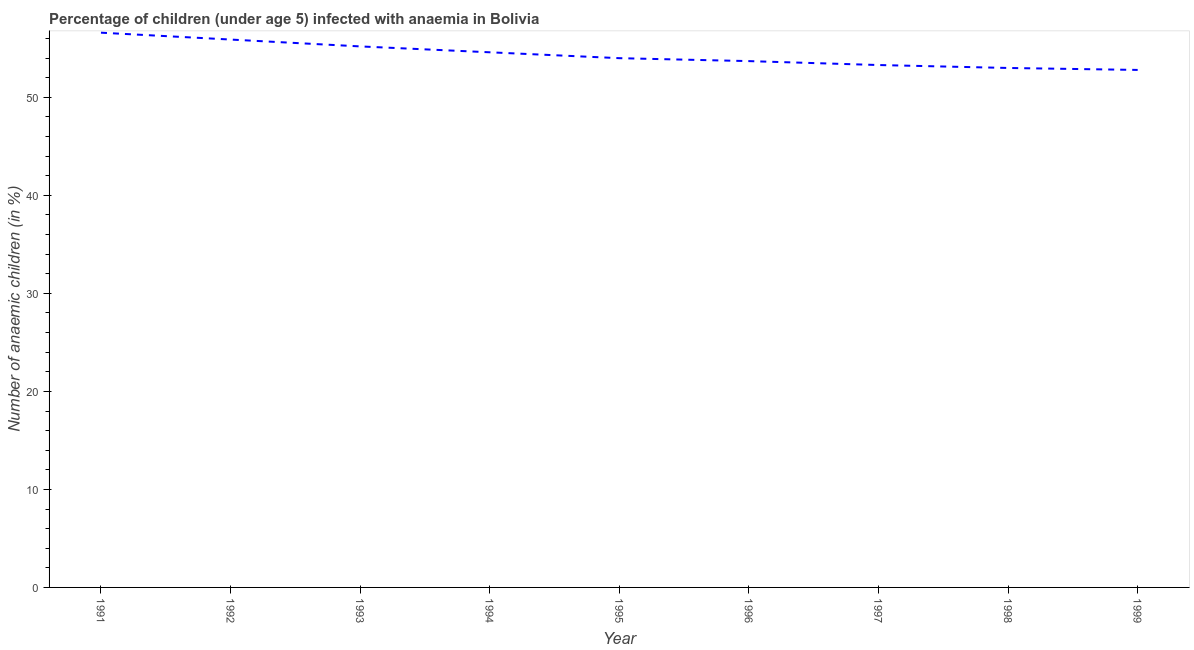What is the number of anaemic children in 1991?
Provide a short and direct response. 56.6. Across all years, what is the maximum number of anaemic children?
Give a very brief answer. 56.6. Across all years, what is the minimum number of anaemic children?
Make the answer very short. 52.8. In which year was the number of anaemic children maximum?
Offer a terse response. 1991. What is the sum of the number of anaemic children?
Give a very brief answer. 489.1. What is the difference between the number of anaemic children in 1992 and 1998?
Offer a terse response. 2.9. What is the average number of anaemic children per year?
Give a very brief answer. 54.34. What is the median number of anaemic children?
Keep it short and to the point. 54. In how many years, is the number of anaemic children greater than 46 %?
Make the answer very short. 9. Do a majority of the years between 1996 and 1991 (inclusive) have number of anaemic children greater than 26 %?
Your answer should be very brief. Yes. What is the ratio of the number of anaemic children in 1995 to that in 1999?
Make the answer very short. 1.02. Is the number of anaemic children in 1991 less than that in 1997?
Your response must be concise. No. Is the difference between the number of anaemic children in 1997 and 1999 greater than the difference between any two years?
Keep it short and to the point. No. What is the difference between the highest and the second highest number of anaemic children?
Your response must be concise. 0.7. What is the difference between the highest and the lowest number of anaemic children?
Ensure brevity in your answer.  3.8. Does the number of anaemic children monotonically increase over the years?
Provide a succinct answer. No. What is the difference between two consecutive major ticks on the Y-axis?
Provide a succinct answer. 10. What is the title of the graph?
Your response must be concise. Percentage of children (under age 5) infected with anaemia in Bolivia. What is the label or title of the X-axis?
Offer a very short reply. Year. What is the label or title of the Y-axis?
Your answer should be compact. Number of anaemic children (in %). What is the Number of anaemic children (in %) in 1991?
Make the answer very short. 56.6. What is the Number of anaemic children (in %) in 1992?
Offer a very short reply. 55.9. What is the Number of anaemic children (in %) in 1993?
Ensure brevity in your answer.  55.2. What is the Number of anaemic children (in %) of 1994?
Provide a succinct answer. 54.6. What is the Number of anaemic children (in %) of 1995?
Ensure brevity in your answer.  54. What is the Number of anaemic children (in %) of 1996?
Provide a short and direct response. 53.7. What is the Number of anaemic children (in %) of 1997?
Your answer should be compact. 53.3. What is the Number of anaemic children (in %) of 1999?
Keep it short and to the point. 52.8. What is the difference between the Number of anaemic children (in %) in 1991 and 1992?
Your response must be concise. 0.7. What is the difference between the Number of anaemic children (in %) in 1991 and 1993?
Provide a short and direct response. 1.4. What is the difference between the Number of anaemic children (in %) in 1991 and 1994?
Offer a terse response. 2. What is the difference between the Number of anaemic children (in %) in 1991 and 1996?
Keep it short and to the point. 2.9. What is the difference between the Number of anaemic children (in %) in 1991 and 1997?
Provide a succinct answer. 3.3. What is the difference between the Number of anaemic children (in %) in 1991 and 1999?
Your response must be concise. 3.8. What is the difference between the Number of anaemic children (in %) in 1992 and 1994?
Keep it short and to the point. 1.3. What is the difference between the Number of anaemic children (in %) in 1992 and 1995?
Offer a terse response. 1.9. What is the difference between the Number of anaemic children (in %) in 1992 and 1996?
Provide a succinct answer. 2.2. What is the difference between the Number of anaemic children (in %) in 1992 and 1997?
Provide a short and direct response. 2.6. What is the difference between the Number of anaemic children (in %) in 1993 and 1994?
Keep it short and to the point. 0.6. What is the difference between the Number of anaemic children (in %) in 1993 and 1995?
Offer a very short reply. 1.2. What is the difference between the Number of anaemic children (in %) in 1994 and 1995?
Give a very brief answer. 0.6. What is the difference between the Number of anaemic children (in %) in 1994 and 1996?
Keep it short and to the point. 0.9. What is the difference between the Number of anaemic children (in %) in 1994 and 1997?
Provide a short and direct response. 1.3. What is the difference between the Number of anaemic children (in %) in 1994 and 1998?
Give a very brief answer. 1.6. What is the difference between the Number of anaemic children (in %) in 1995 and 1996?
Your answer should be very brief. 0.3. What is the difference between the Number of anaemic children (in %) in 1995 and 1997?
Provide a short and direct response. 0.7. What is the difference between the Number of anaemic children (in %) in 1996 and 1997?
Offer a terse response. 0.4. What is the difference between the Number of anaemic children (in %) in 1997 and 1999?
Keep it short and to the point. 0.5. What is the difference between the Number of anaemic children (in %) in 1998 and 1999?
Provide a succinct answer. 0.2. What is the ratio of the Number of anaemic children (in %) in 1991 to that in 1993?
Ensure brevity in your answer.  1.02. What is the ratio of the Number of anaemic children (in %) in 1991 to that in 1995?
Provide a short and direct response. 1.05. What is the ratio of the Number of anaemic children (in %) in 1991 to that in 1996?
Provide a short and direct response. 1.05. What is the ratio of the Number of anaemic children (in %) in 1991 to that in 1997?
Your answer should be compact. 1.06. What is the ratio of the Number of anaemic children (in %) in 1991 to that in 1998?
Provide a short and direct response. 1.07. What is the ratio of the Number of anaemic children (in %) in 1991 to that in 1999?
Keep it short and to the point. 1.07. What is the ratio of the Number of anaemic children (in %) in 1992 to that in 1993?
Provide a succinct answer. 1.01. What is the ratio of the Number of anaemic children (in %) in 1992 to that in 1994?
Offer a very short reply. 1.02. What is the ratio of the Number of anaemic children (in %) in 1992 to that in 1995?
Your answer should be compact. 1.03. What is the ratio of the Number of anaemic children (in %) in 1992 to that in 1996?
Make the answer very short. 1.04. What is the ratio of the Number of anaemic children (in %) in 1992 to that in 1997?
Keep it short and to the point. 1.05. What is the ratio of the Number of anaemic children (in %) in 1992 to that in 1998?
Offer a very short reply. 1.05. What is the ratio of the Number of anaemic children (in %) in 1992 to that in 1999?
Your answer should be very brief. 1.06. What is the ratio of the Number of anaemic children (in %) in 1993 to that in 1994?
Your response must be concise. 1.01. What is the ratio of the Number of anaemic children (in %) in 1993 to that in 1996?
Ensure brevity in your answer.  1.03. What is the ratio of the Number of anaemic children (in %) in 1993 to that in 1997?
Offer a very short reply. 1.04. What is the ratio of the Number of anaemic children (in %) in 1993 to that in 1998?
Give a very brief answer. 1.04. What is the ratio of the Number of anaemic children (in %) in 1993 to that in 1999?
Ensure brevity in your answer.  1.04. What is the ratio of the Number of anaemic children (in %) in 1994 to that in 1996?
Your answer should be very brief. 1.02. What is the ratio of the Number of anaemic children (in %) in 1994 to that in 1999?
Provide a short and direct response. 1.03. What is the ratio of the Number of anaemic children (in %) in 1995 to that in 1996?
Your answer should be compact. 1.01. What is the ratio of the Number of anaemic children (in %) in 1995 to that in 1997?
Your answer should be compact. 1.01. What is the ratio of the Number of anaemic children (in %) in 1995 to that in 1999?
Offer a terse response. 1.02. What is the ratio of the Number of anaemic children (in %) in 1996 to that in 1997?
Provide a short and direct response. 1.01. What is the ratio of the Number of anaemic children (in %) in 1996 to that in 1999?
Make the answer very short. 1.02. What is the ratio of the Number of anaemic children (in %) in 1997 to that in 1998?
Offer a terse response. 1.01. What is the ratio of the Number of anaemic children (in %) in 1997 to that in 1999?
Offer a terse response. 1.01. What is the ratio of the Number of anaemic children (in %) in 1998 to that in 1999?
Offer a terse response. 1. 